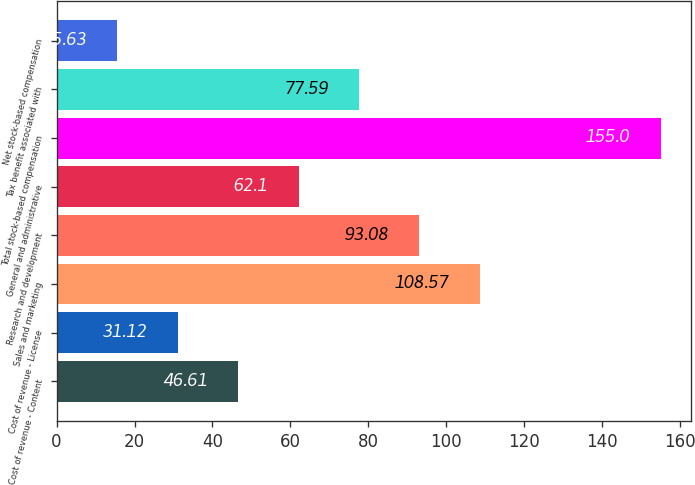Convert chart to OTSL. <chart><loc_0><loc_0><loc_500><loc_500><bar_chart><fcel>Cost of revenue - Content<fcel>Cost of revenue - License<fcel>Sales and marketing<fcel>Research and development<fcel>General and administrative<fcel>Total stock-based compensation<fcel>Tax benefit associated with<fcel>Net stock-based compensation<nl><fcel>46.61<fcel>31.12<fcel>108.57<fcel>93.08<fcel>62.1<fcel>155<fcel>77.59<fcel>15.63<nl></chart> 